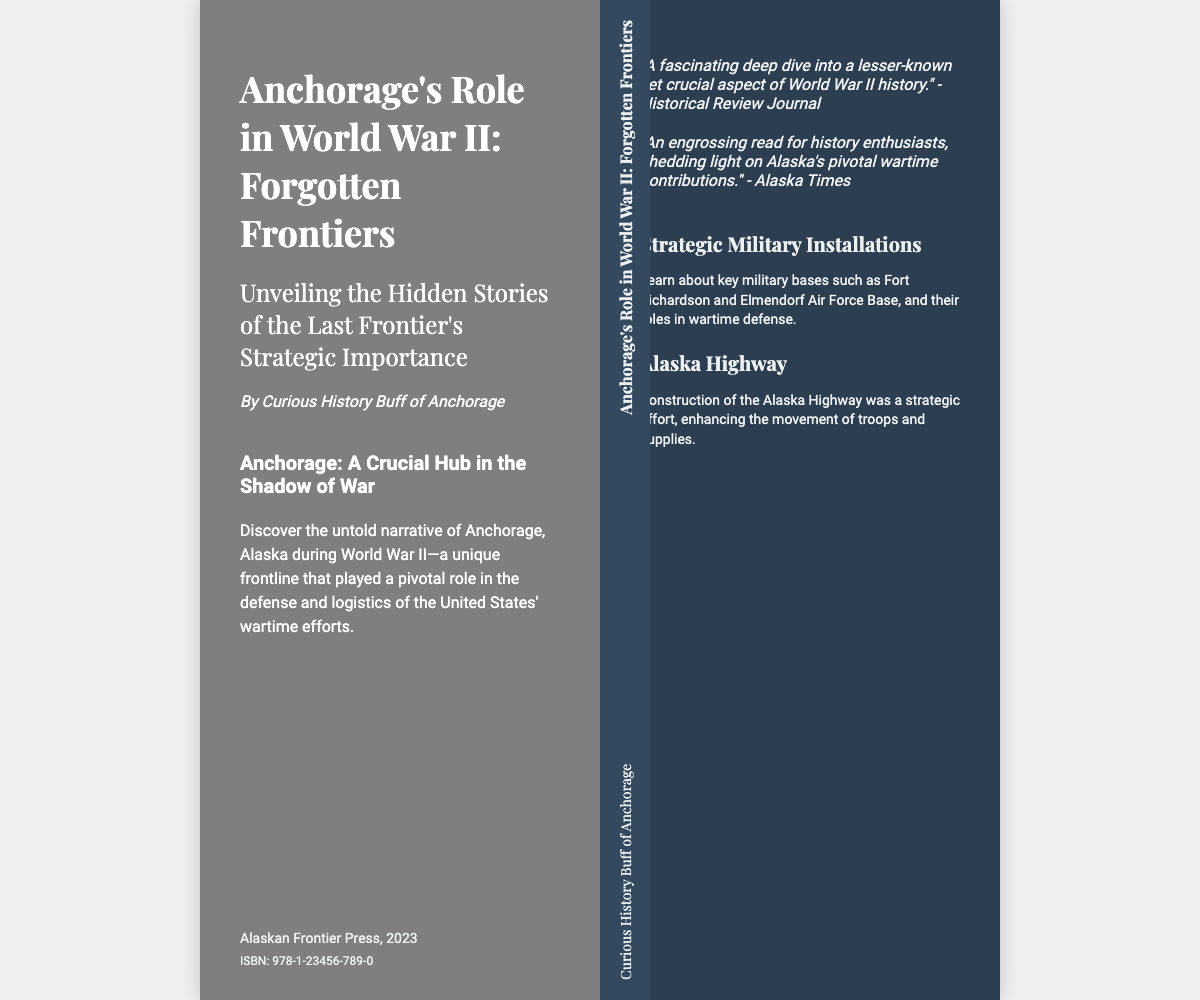What is the title of the book? The title is prominently displayed on the front cover of the document.
Answer: Anchorage's Role in World War II: Forgotten Frontiers Who is the author of the book? The author's name is mentioned directly under the title on the front cover.
Answer: Curious History Buff of Anchorage What year was the book published? The publication year is located on the back cover of the document.
Answer: 2023 What is the ISBN number of the book? The ISBN is found on the back cover and is a unique identifier for the book.
Answer: 978-1-23456-789-0 What military installation is mentioned in the description? The description of the book highlights key military bases as part of its content.
Answer: Fort Richardson What highway is discussed in the context of the book? The additional information section on the back cover mentions this highway.
Answer: Alaska Highway What type of book is this document representing? This document represents a book cover, which includes typical elements such as title, author, and description.
Answer: Book What does the headline on the front cover emphasize? The headline summarizes the focus of the book as described on the cover.
Answer: A Crucial Hub in the Shadow of War Which publication reviewed the book? Reviews are included on the back cover, providing insights from recognized sources.
Answer: Historical Review Journal 